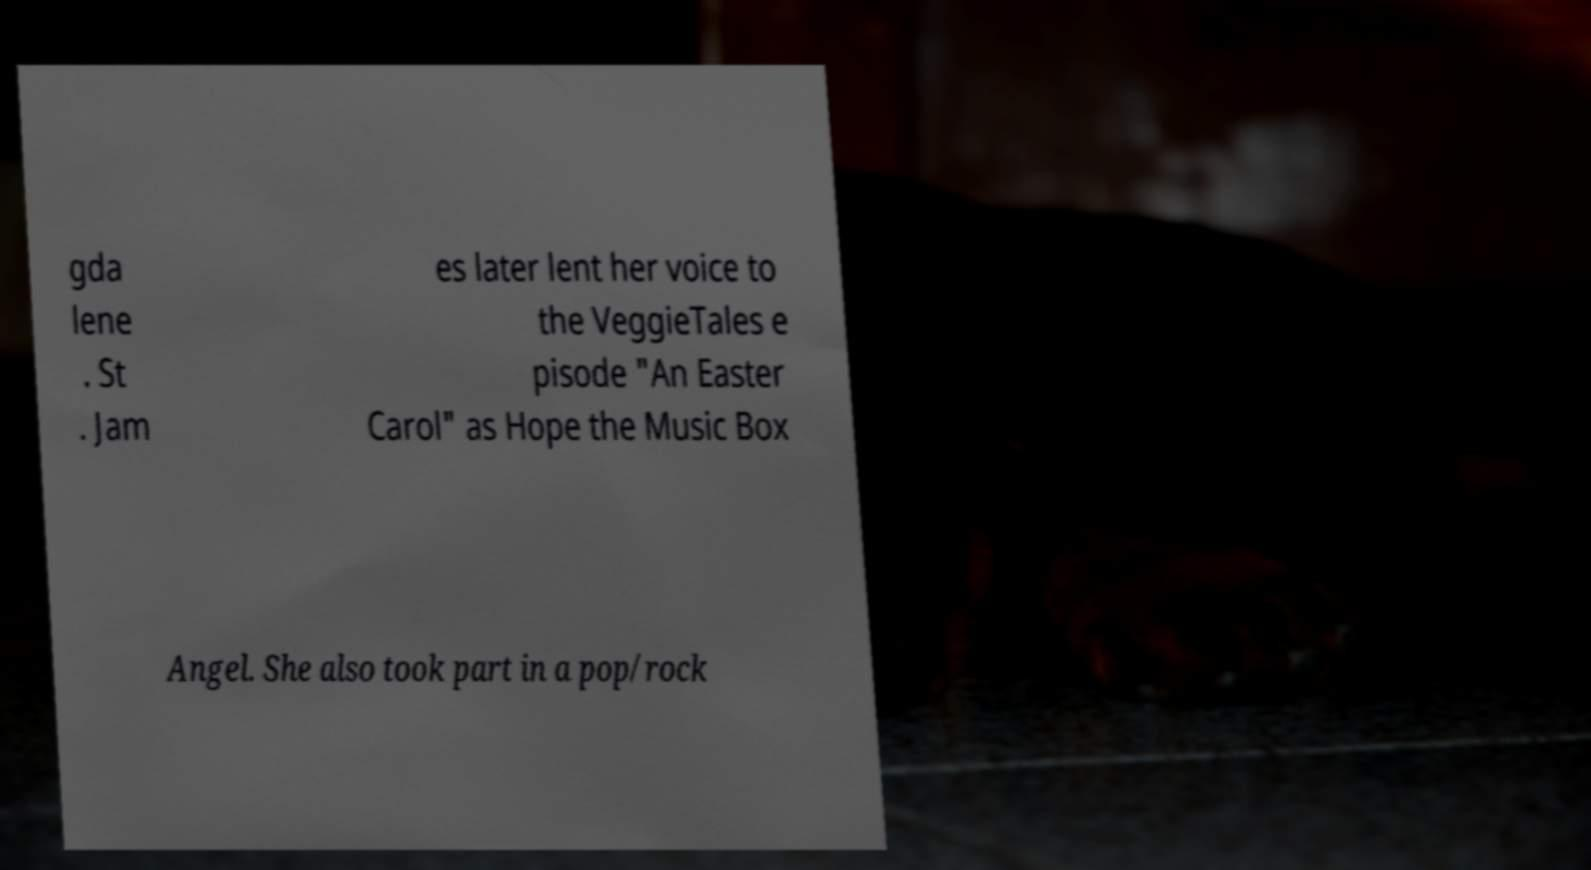What messages or text are displayed in this image? I need them in a readable, typed format. gda lene . St . Jam es later lent her voice to the VeggieTales e pisode "An Easter Carol" as Hope the Music Box Angel. She also took part in a pop/rock 